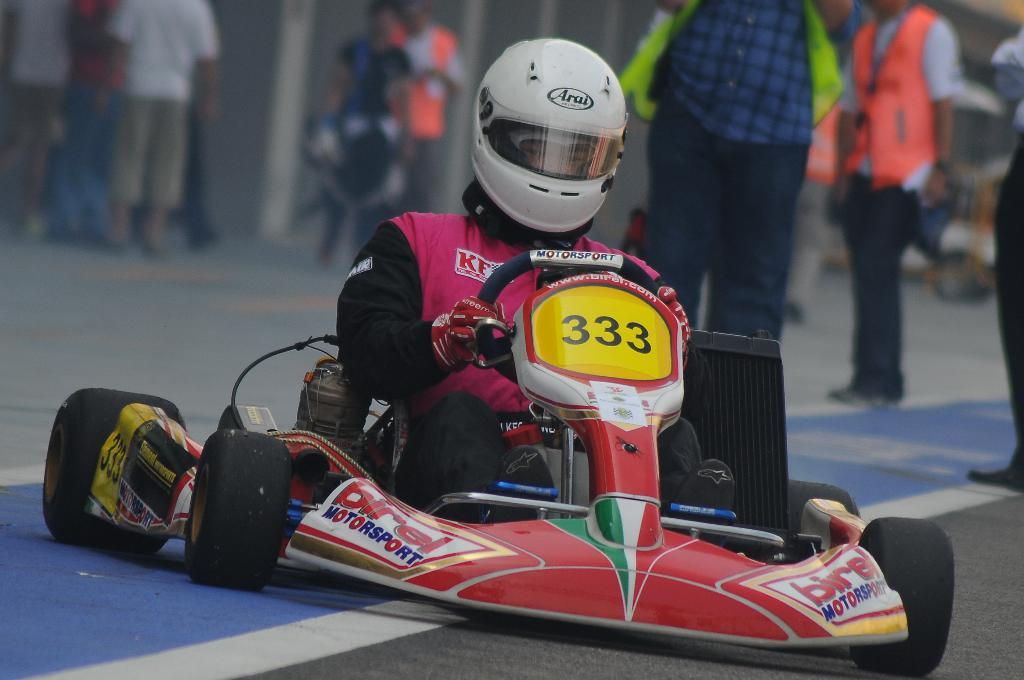What activity is the man in the image participating in? The man is doing go-karting. What safety equipment is the man wearing? The man is wearing a helmet. Can you describe the people behind the man? There are people behind the man, but their specific actions or characteristics are not mentioned in the facts. What type of receipt can be seen in the man's hand in the image? There is no receipt visible in the man's hand in the image. How does the man's desire to win affect his performance in the image? The man's desire to win is not mentioned in the facts, so we cannot determine its effect on his performance. 